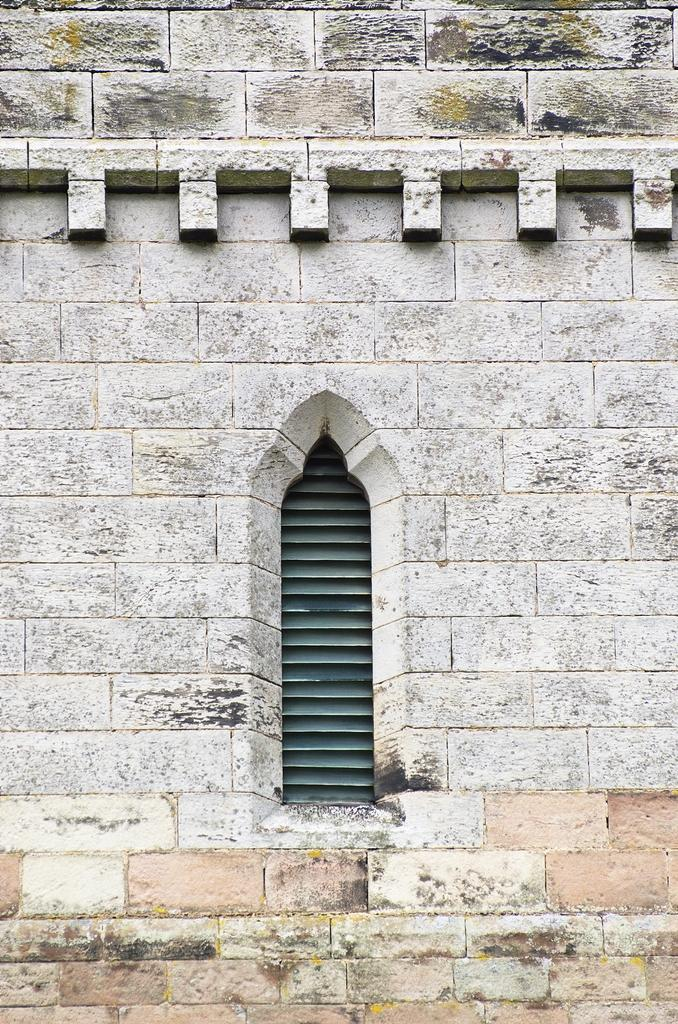What is the main structure visible in the image? There is a wall of a building in the image. Are there any openings in the wall? Yes, there is a window on the wall. What material is the wall made of? The wall of the building is made up of stone bricks. How many rabbits can be seen learning on the wrist in the image? There are no rabbits or any learning activity visible in the image. 